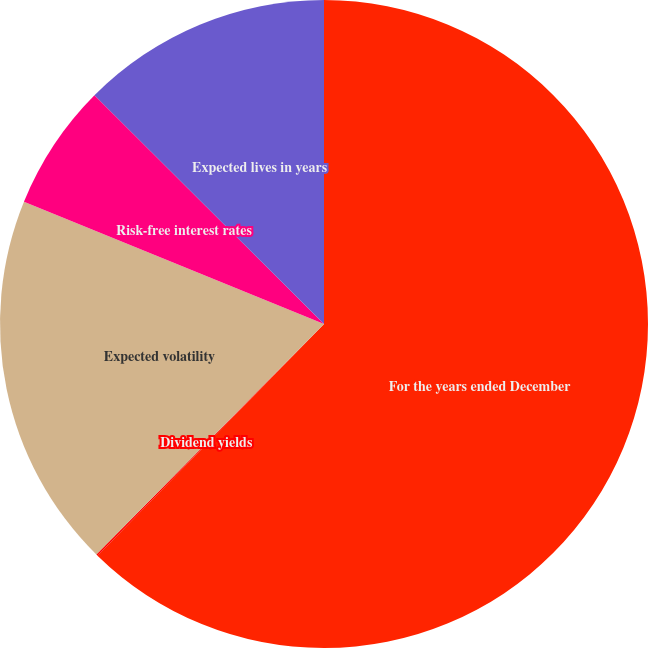Convert chart. <chart><loc_0><loc_0><loc_500><loc_500><pie_chart><fcel>For the years ended December<fcel>Dividend yields<fcel>Expected volatility<fcel>Risk-free interest rates<fcel>Expected lives in years<nl><fcel>62.32%<fcel>0.08%<fcel>18.76%<fcel>6.31%<fcel>12.53%<nl></chart> 